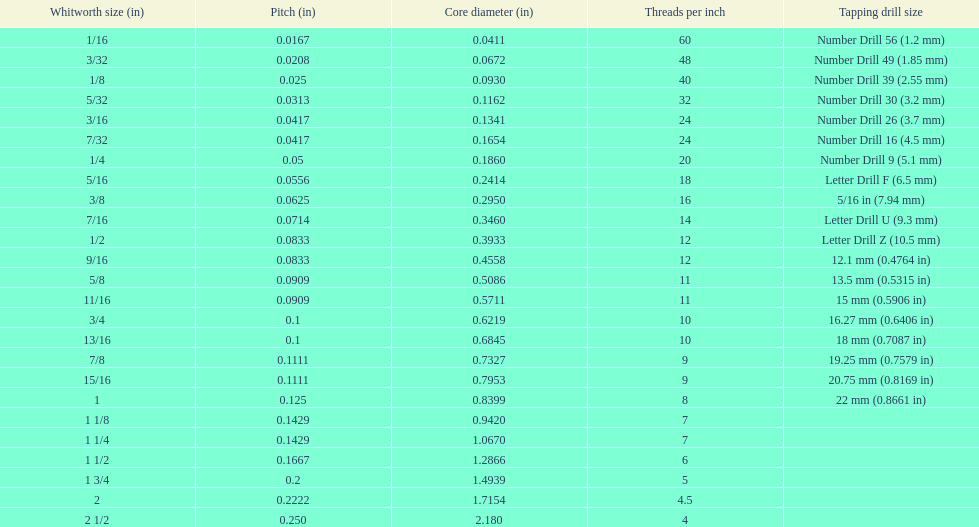Does any whitworth size have the same core diameter as the number drill 26? 3/16. 